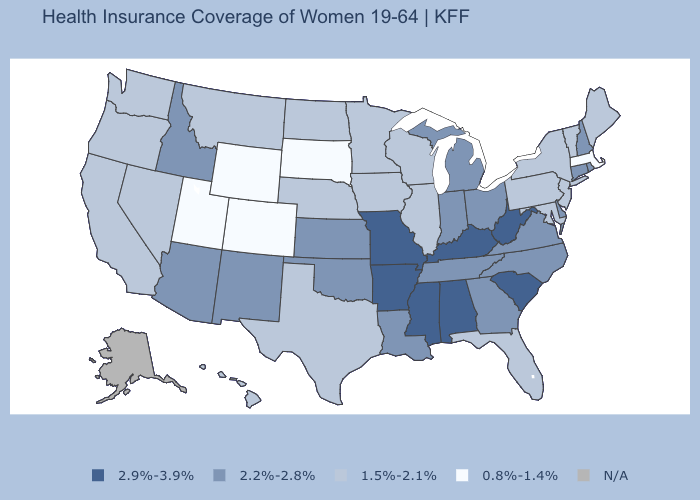What is the value of Idaho?
Concise answer only. 2.2%-2.8%. What is the value of Rhode Island?
Write a very short answer. 2.2%-2.8%. What is the value of Rhode Island?
Be succinct. 2.2%-2.8%. Name the states that have a value in the range 0.8%-1.4%?
Short answer required. Colorado, Massachusetts, South Dakota, Utah, Wyoming. Does Mississippi have the highest value in the USA?
Quick response, please. Yes. How many symbols are there in the legend?
Keep it brief. 5. Among the states that border Colorado , does New Mexico have the highest value?
Short answer required. Yes. What is the value of Wyoming?
Answer briefly. 0.8%-1.4%. Among the states that border New Mexico , does Oklahoma have the lowest value?
Answer briefly. No. Name the states that have a value in the range 1.5%-2.1%?
Answer briefly. California, Florida, Hawaii, Illinois, Iowa, Maine, Maryland, Minnesota, Montana, Nebraska, Nevada, New Jersey, New York, North Dakota, Oregon, Pennsylvania, Texas, Vermont, Washington, Wisconsin. What is the value of Indiana?
Short answer required. 2.2%-2.8%. Among the states that border Arkansas , which have the highest value?
Quick response, please. Mississippi, Missouri. What is the highest value in states that border Oklahoma?
Write a very short answer. 2.9%-3.9%. What is the highest value in the MidWest ?
Give a very brief answer. 2.9%-3.9%. 